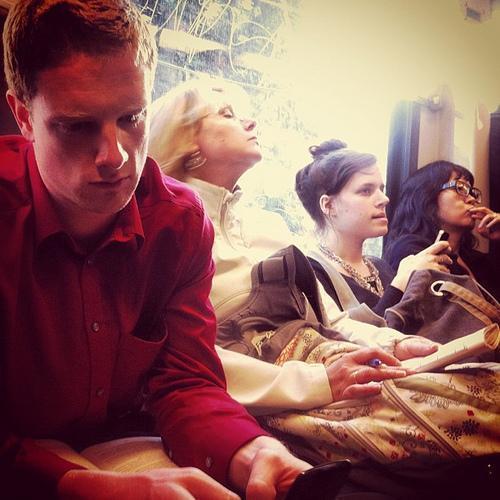How many people are in the photo?
Give a very brief answer. 4. 